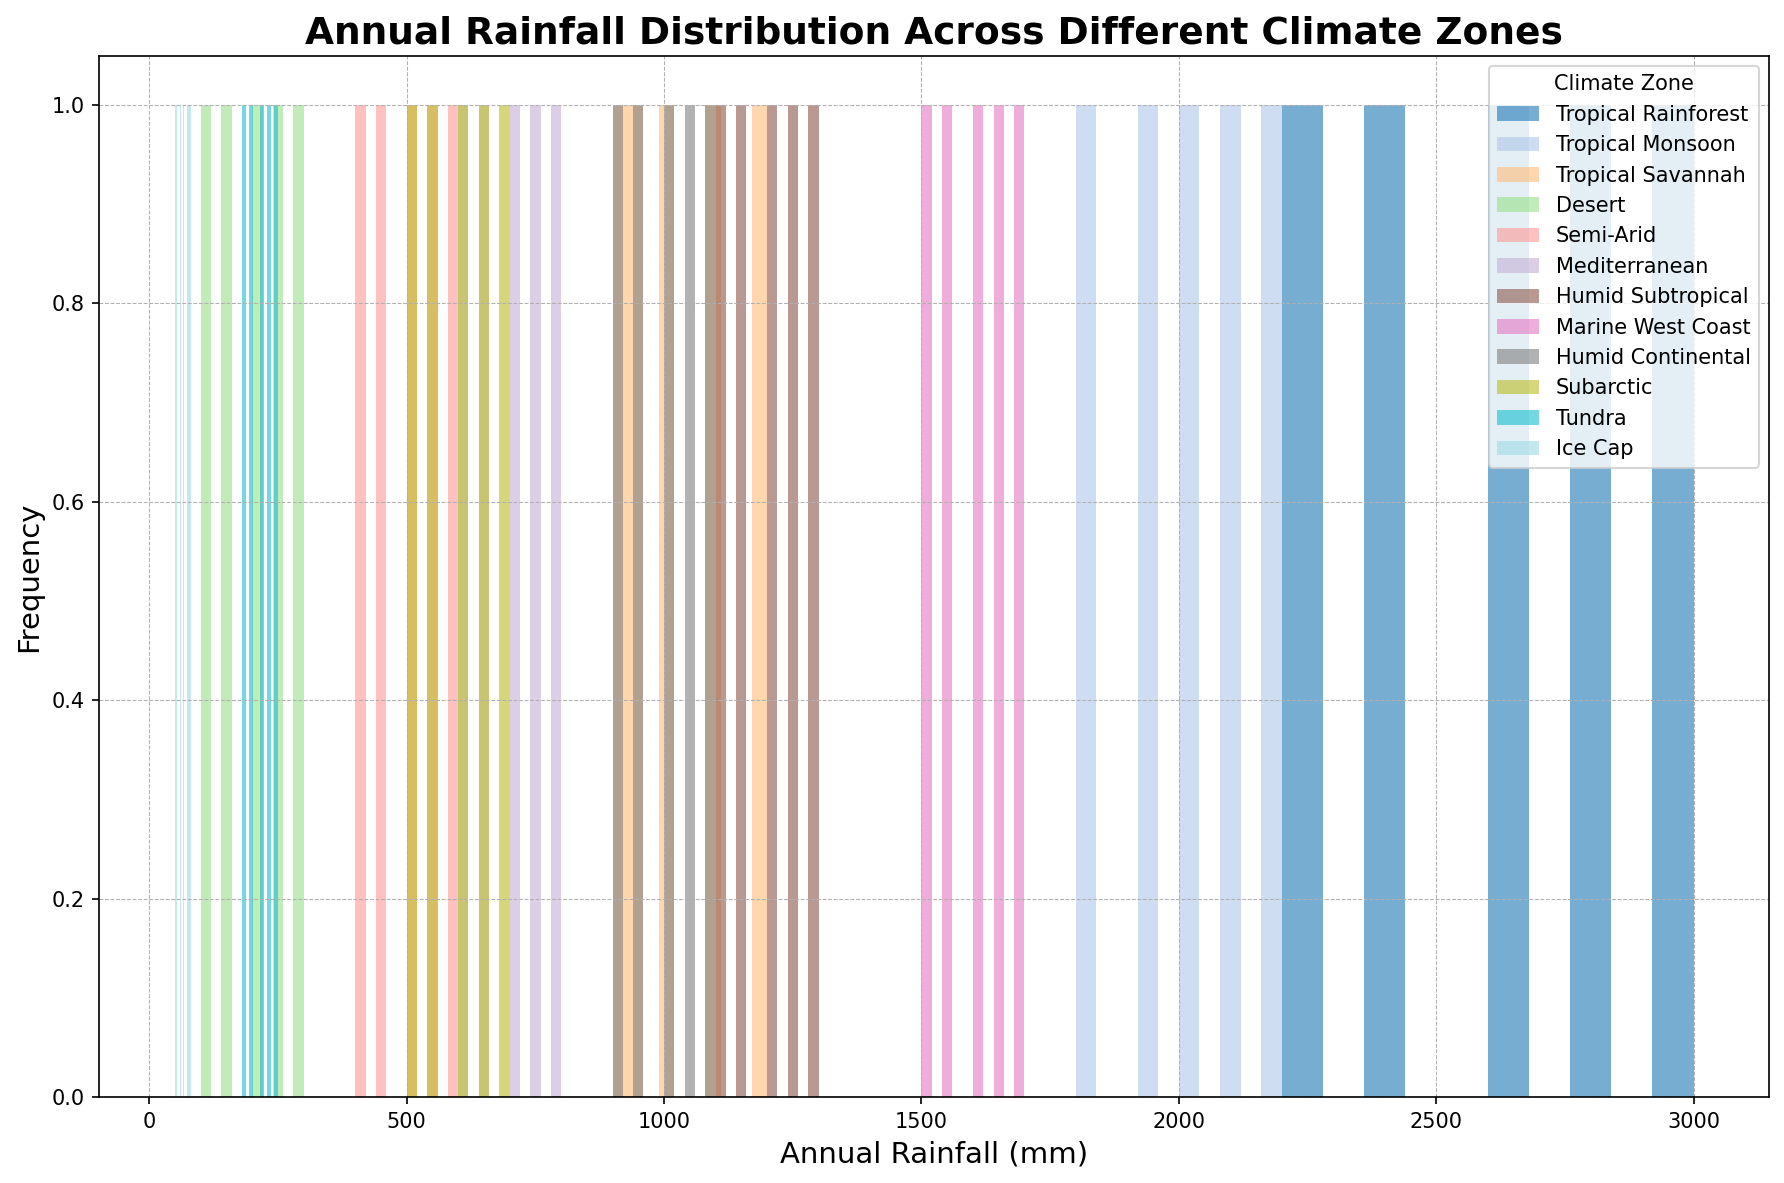Which climate zone has the highest average annual rainfall? First, visually identify the climate zone with the highest bar heights in terms of 'Annual Rainfall'. By observing the histogram, it seems that the Tropical Rainforest climate zone has the highest values. Averaging its rainfall values (2200, 2600, 2400, 2800, 3000) gives an average rainfall of (2200+2600+2400+2800+3000)/5 = 2600 mm
Answer: Tropical Rainforest Which climate zone receives the least annual rainfall on average? Identify the climate zone with the lowest overall bar heights. By looking at the histogram, you can see the Ice Cap climate zone has the smallest values. Averaging its rainfall values (50, 75, 60, 65, 80) results in (50+75+60+65+80)/5 = 66 mm
Answer: Ice Cap Is there any climate zone where the range of annual rainfall exceeds 1500 mm? To find this, check the spreads of the bars for each climate zone. The Tropical Rainforest ranges from 2200 mm to 3000 mm, a span of 3000 - 2200 = 800 mm. No other climate zone range exceeds 1500 mm.
Answer: No Which two climate zones have the most overlap in their annual rainfall distribution? Overlap can be observed by finding the regions where the histograms of different zones intersect. The annual rainfall for Tropical Monsoon (1800-2200 mm) and Humid Subtropical (1100-1300 mm) seem to overlap the most visually.
Answer: Tropical Monsoon and Humid Subtropical What is the most frequent rainfall value range for the Subarctic zone? Identify the bin or range where the tallest bar for the Subarctic zone is located. The Subarctic zone values appear most frequently around 500-700 mm.
Answer: 500-700 mm How many climate zones have a maximum annual rainfall less than 1000 mm? Determine the maximum rainfall for each climate zone by checking the range of values. The zones with a maximum rainfall less than 1000 mm are Desert, Semi-Arid, Tundra, and Ice Cap. Count these zones: 4
Answer: 4 Does any climate zone have a uniform distribution of annual rainfall? Observing the histograms, look for a zone where the bars are roughly equal in height. The Mediterranean zone seems to have a comparatively uniform distribution between 600 and 800 mm.
Answer: Mediterranean Which climate zone has the lowest variability in its annual rainfall? Visualize the histograms and find the spread of values for each zone. Ice Cap shows the mostly clustered values around the lower end (50-80 mm) with minimal spread, indicating low variability.
Answer: Ice Cap 